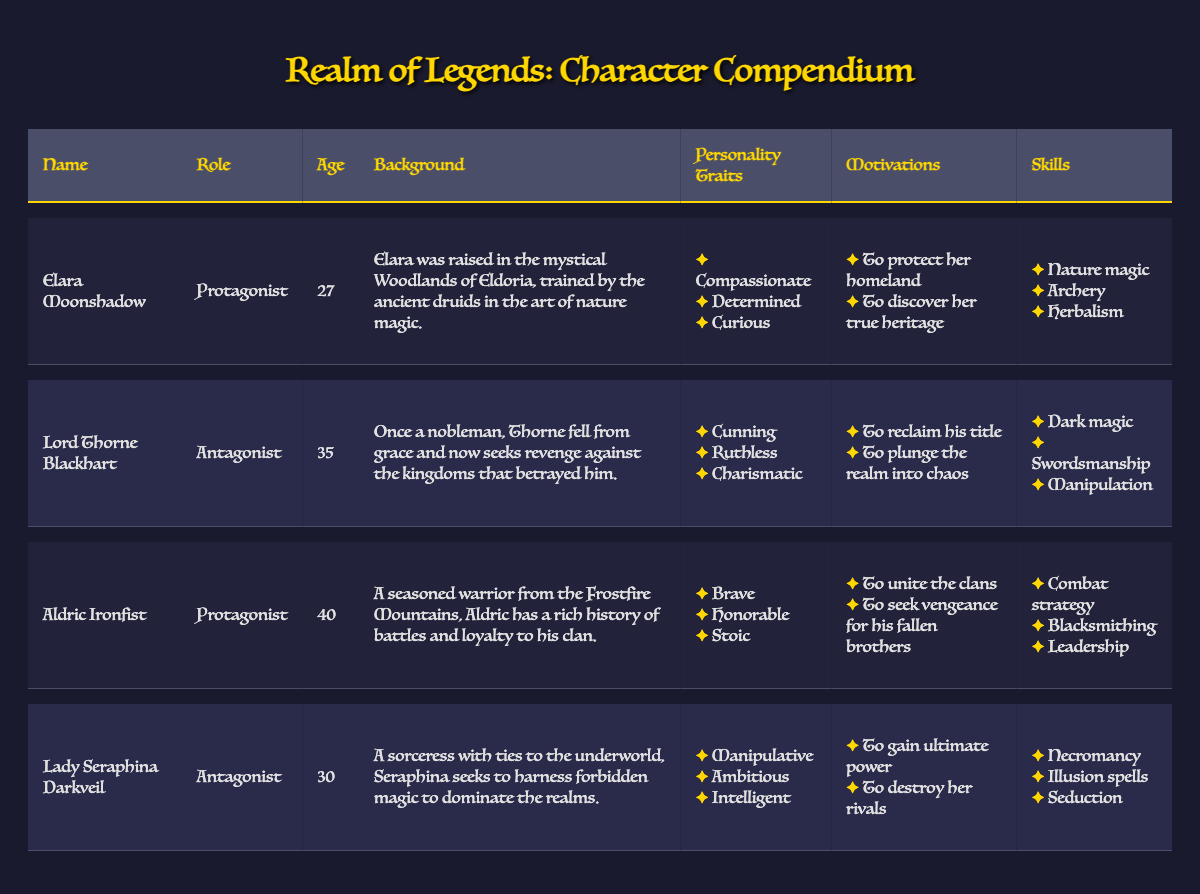What is the age of Elara Moonshadow? Elara Moonshadow's age is explicitly stated in the table under the "Age" column.
Answer: 27 What are the main skills of Lord Thorne Blackhart? The skills of Lord Thorne Blackhart can be found in the "Skills" column for his row in the table, which lists three skills: dark magic, swordsmanship, and manipulation.
Answer: Dark magic, swordsmanship, manipulation Who has the motivation to protect their homeland? The motivation to protect her homeland is listed under Elara Moonshadow's motivations.
Answer: Elara Moonshadow Is Aldric Ironfist an antagonist? Aldric Ironfist's role is mentioned in the "Role" column, which indicates he is a protagonist, thus making this statement false.
Answer: No Which character has the personality trait "manipulative"? The trait "manipulative" is found under the personality traits for Lady Seraphina Darkveil in the respective row.
Answer: Lady Seraphina Darkveil What is the average age of the protagonists? There are two protagonists listed in the table: Elara Moonshadow (27) and Aldric Ironfist (40). To find the average, add their ages (27 + 40 = 67) and divide by the number of protagonists (2) to get an average age of 33.5.
Answer: 33.5 Who has the motivation to gain ultimate power? The motivation to gain ultimate power can be found in the motivations list for Lady Seraphina Darkveil.
Answer: Lady Seraphina Darkveil What personality traits differentiate the two antagonists? The personality traits for each antagonist are listed, with Lord Thorne Blackhart having cunning, ruthless, and charismatic traits, while Lady Seraphina Darkveil has manipulative, ambitious, and intelligent traits, showcasing their differing natures.
Answer: Cunning, ruthless, charismatic (Lord Thorne), Manipulative, ambitious, intelligent (Lady Seraphina) Which character is older, Lord Thorne Blackhart or Lady Seraphina Darkveil? Lord Thorne Blackhart is 35 years old, while Lady Seraphina Darkveil is 30. By comparing these ages, we find that Lord Thorne is older.
Answer: Lord Thorne Blackhart 